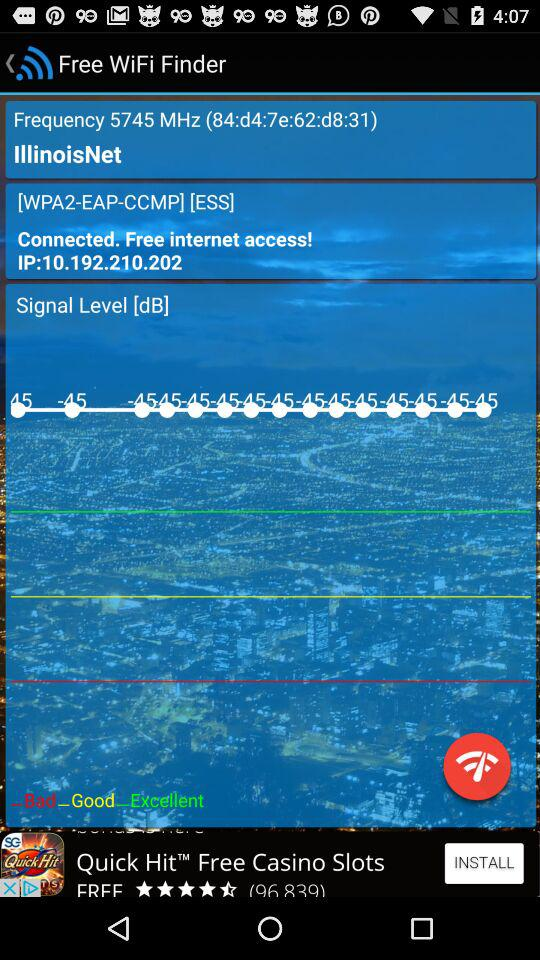What is the name of the application? The name of the application is "Free WiFi Finder". 